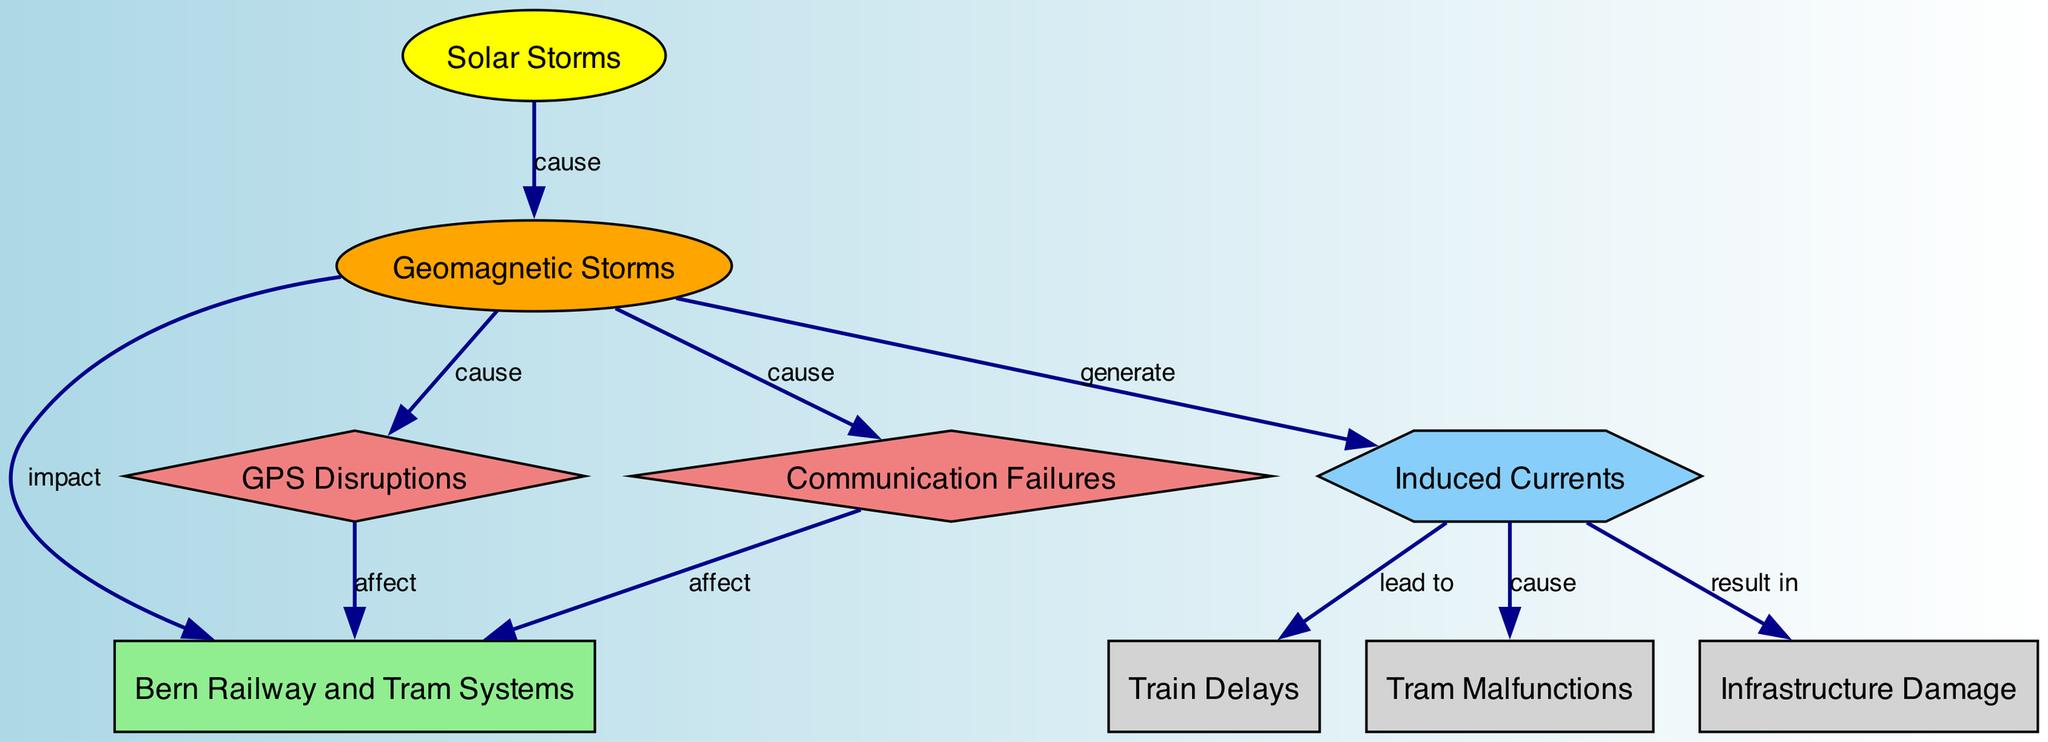What causes geomagnetic storms? The diagram shows that solar storms are indicated to cause geomagnetic storms. This can be seen from the directed edge from "solar_storms" to "geomagnetic_storms" labeled "cause."
Answer: solar storms What is the relationship between geomagnetic storms and Bern Railway and Tram Systems? The diagram indicates that geomagnetic storms impact the Bern railway and tram systems. This is represented by the edge from "geomagnetic_storms" to "bern_railway_tram_systems" with the label "impact."
Answer: impact How many nodes are there in the diagram? By counting the distinct elements labeled in the diagram, there are a total of eight nodes indicating various entities related to solar storms and their effects.
Answer: eight What impacts GPS disruptions? The diagram shows that GPS disruptions are affected by geomagnetic storms. This is found where "gps_disruptions" is connected to "geomagnetic_storms" with the edge labeled "cause."
Answer: geomagnetic storms What is the outcome of induced currents according to the diagram? Induced currents lead to multiple outcomes in the diagram, including train delays, tram malfunctions, and infrastructure damage. Hence, they result in train delays as shown from "induced_currents" leading to "train_delays."
Answer: train delays Which type of disruptions can geomagnetic storms cause? The diagram indicates that geomagnetic storms can cause communication failures and GPS disruptions, both of which are affected directly by geomagnetic storms, as denoted by the "cause" edges connecting them.
Answer: communication failures What leads to tram malfunctions? The diagram illustrates that induced currents cause tram malfunctions. The directed edge from "induced_currents" to "tram_malfunctions" clearly shows this relationship labeled "cause."
Answer: induced currents How many edges are there in the diagram? By examining the connections between the nodes, there are a total of ten directed edges depicting the relationships and influences outlined in the diagram.
Answer: ten 